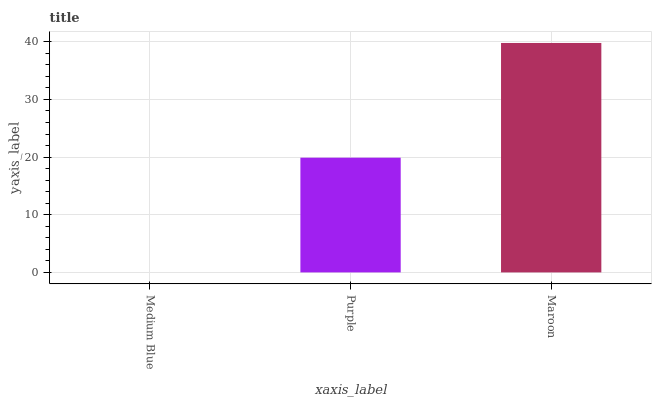Is Medium Blue the minimum?
Answer yes or no. Yes. Is Maroon the maximum?
Answer yes or no. Yes. Is Purple the minimum?
Answer yes or no. No. Is Purple the maximum?
Answer yes or no. No. Is Purple greater than Medium Blue?
Answer yes or no. Yes. Is Medium Blue less than Purple?
Answer yes or no. Yes. Is Medium Blue greater than Purple?
Answer yes or no. No. Is Purple less than Medium Blue?
Answer yes or no. No. Is Purple the high median?
Answer yes or no. Yes. Is Purple the low median?
Answer yes or no. Yes. Is Medium Blue the high median?
Answer yes or no. No. Is Maroon the low median?
Answer yes or no. No. 